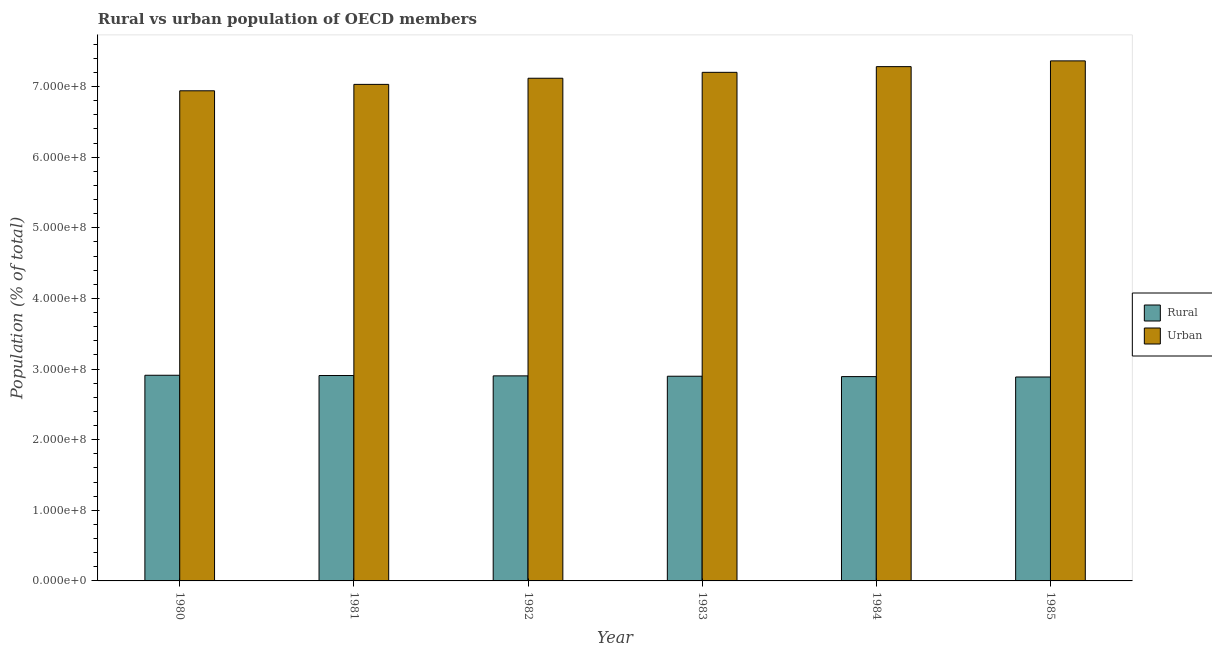How many groups of bars are there?
Keep it short and to the point. 6. Are the number of bars per tick equal to the number of legend labels?
Keep it short and to the point. Yes. Are the number of bars on each tick of the X-axis equal?
Provide a short and direct response. Yes. How many bars are there on the 1st tick from the right?
Give a very brief answer. 2. What is the rural population density in 1982?
Ensure brevity in your answer.  2.90e+08. Across all years, what is the maximum urban population density?
Make the answer very short. 7.36e+08. Across all years, what is the minimum rural population density?
Provide a succinct answer. 2.89e+08. In which year was the rural population density maximum?
Ensure brevity in your answer.  1980. What is the total rural population density in the graph?
Provide a succinct answer. 1.74e+09. What is the difference between the urban population density in 1981 and that in 1985?
Your response must be concise. -3.33e+07. What is the difference between the urban population density in 1980 and the rural population density in 1983?
Your response must be concise. -2.61e+07. What is the average urban population density per year?
Offer a very short reply. 7.16e+08. What is the ratio of the rural population density in 1981 to that in 1984?
Provide a succinct answer. 1.01. Is the rural population density in 1981 less than that in 1985?
Your answer should be compact. No. What is the difference between the highest and the second highest urban population density?
Your response must be concise. 8.16e+06. What is the difference between the highest and the lowest urban population density?
Offer a terse response. 4.24e+07. Is the sum of the urban population density in 1980 and 1984 greater than the maximum rural population density across all years?
Make the answer very short. Yes. What does the 2nd bar from the left in 1982 represents?
Offer a terse response. Urban. What does the 2nd bar from the right in 1980 represents?
Your answer should be compact. Rural. How many bars are there?
Give a very brief answer. 12. Are all the bars in the graph horizontal?
Give a very brief answer. No. How many years are there in the graph?
Make the answer very short. 6. What is the difference between two consecutive major ticks on the Y-axis?
Ensure brevity in your answer.  1.00e+08. Are the values on the major ticks of Y-axis written in scientific E-notation?
Your answer should be very brief. Yes. Does the graph contain any zero values?
Offer a very short reply. No. Where does the legend appear in the graph?
Keep it short and to the point. Center right. How are the legend labels stacked?
Provide a succinct answer. Vertical. What is the title of the graph?
Give a very brief answer. Rural vs urban population of OECD members. What is the label or title of the Y-axis?
Offer a terse response. Population (% of total). What is the Population (% of total) of Rural in 1980?
Provide a succinct answer. 2.91e+08. What is the Population (% of total) of Urban in 1980?
Give a very brief answer. 6.94e+08. What is the Population (% of total) of Rural in 1981?
Your answer should be compact. 2.91e+08. What is the Population (% of total) in Urban in 1981?
Ensure brevity in your answer.  7.03e+08. What is the Population (% of total) of Rural in 1982?
Offer a very short reply. 2.90e+08. What is the Population (% of total) in Urban in 1982?
Offer a very short reply. 7.12e+08. What is the Population (% of total) in Rural in 1983?
Offer a very short reply. 2.90e+08. What is the Population (% of total) of Urban in 1983?
Offer a very short reply. 7.20e+08. What is the Population (% of total) of Rural in 1984?
Your answer should be very brief. 2.89e+08. What is the Population (% of total) in Urban in 1984?
Ensure brevity in your answer.  7.28e+08. What is the Population (% of total) in Rural in 1985?
Keep it short and to the point. 2.89e+08. What is the Population (% of total) in Urban in 1985?
Keep it short and to the point. 7.36e+08. Across all years, what is the maximum Population (% of total) in Rural?
Keep it short and to the point. 2.91e+08. Across all years, what is the maximum Population (% of total) of Urban?
Make the answer very short. 7.36e+08. Across all years, what is the minimum Population (% of total) in Rural?
Offer a terse response. 2.89e+08. Across all years, what is the minimum Population (% of total) of Urban?
Keep it short and to the point. 6.94e+08. What is the total Population (% of total) of Rural in the graph?
Offer a very short reply. 1.74e+09. What is the total Population (% of total) of Urban in the graph?
Provide a short and direct response. 4.29e+09. What is the difference between the Population (% of total) in Rural in 1980 and that in 1981?
Provide a succinct answer. 3.88e+05. What is the difference between the Population (% of total) of Urban in 1980 and that in 1981?
Provide a short and direct response. -9.08e+06. What is the difference between the Population (% of total) in Rural in 1980 and that in 1982?
Your answer should be compact. 8.75e+05. What is the difference between the Population (% of total) of Urban in 1980 and that in 1982?
Make the answer very short. -1.78e+07. What is the difference between the Population (% of total) in Rural in 1980 and that in 1983?
Your answer should be very brief. 1.37e+06. What is the difference between the Population (% of total) of Urban in 1980 and that in 1983?
Your response must be concise. -2.61e+07. What is the difference between the Population (% of total) in Rural in 1980 and that in 1984?
Keep it short and to the point. 1.90e+06. What is the difference between the Population (% of total) in Urban in 1980 and that in 1984?
Keep it short and to the point. -3.42e+07. What is the difference between the Population (% of total) in Rural in 1980 and that in 1985?
Provide a short and direct response. 2.45e+06. What is the difference between the Population (% of total) in Urban in 1980 and that in 1985?
Your answer should be very brief. -4.24e+07. What is the difference between the Population (% of total) of Rural in 1981 and that in 1982?
Your response must be concise. 4.87e+05. What is the difference between the Population (% of total) of Urban in 1981 and that in 1982?
Provide a short and direct response. -8.70e+06. What is the difference between the Population (% of total) of Rural in 1981 and that in 1983?
Offer a very short reply. 9.79e+05. What is the difference between the Population (% of total) of Urban in 1981 and that in 1983?
Keep it short and to the point. -1.71e+07. What is the difference between the Population (% of total) in Rural in 1981 and that in 1984?
Provide a short and direct response. 1.51e+06. What is the difference between the Population (% of total) of Urban in 1981 and that in 1984?
Keep it short and to the point. -2.51e+07. What is the difference between the Population (% of total) of Rural in 1981 and that in 1985?
Your response must be concise. 2.06e+06. What is the difference between the Population (% of total) of Urban in 1981 and that in 1985?
Your answer should be very brief. -3.33e+07. What is the difference between the Population (% of total) of Rural in 1982 and that in 1983?
Give a very brief answer. 4.91e+05. What is the difference between the Population (% of total) of Urban in 1982 and that in 1983?
Your answer should be compact. -8.36e+06. What is the difference between the Population (% of total) of Rural in 1982 and that in 1984?
Keep it short and to the point. 1.03e+06. What is the difference between the Population (% of total) in Urban in 1982 and that in 1984?
Keep it short and to the point. -1.64e+07. What is the difference between the Population (% of total) of Rural in 1982 and that in 1985?
Offer a very short reply. 1.57e+06. What is the difference between the Population (% of total) of Urban in 1982 and that in 1985?
Give a very brief answer. -2.46e+07. What is the difference between the Population (% of total) in Rural in 1983 and that in 1984?
Offer a very short reply. 5.34e+05. What is the difference between the Population (% of total) of Urban in 1983 and that in 1984?
Your response must be concise. -8.07e+06. What is the difference between the Population (% of total) in Rural in 1983 and that in 1985?
Give a very brief answer. 1.08e+06. What is the difference between the Population (% of total) of Urban in 1983 and that in 1985?
Ensure brevity in your answer.  -1.62e+07. What is the difference between the Population (% of total) in Rural in 1984 and that in 1985?
Your answer should be compact. 5.47e+05. What is the difference between the Population (% of total) of Urban in 1984 and that in 1985?
Give a very brief answer. -8.16e+06. What is the difference between the Population (% of total) of Rural in 1980 and the Population (% of total) of Urban in 1981?
Provide a succinct answer. -4.12e+08. What is the difference between the Population (% of total) of Rural in 1980 and the Population (% of total) of Urban in 1982?
Offer a very short reply. -4.21e+08. What is the difference between the Population (% of total) of Rural in 1980 and the Population (% of total) of Urban in 1983?
Offer a very short reply. -4.29e+08. What is the difference between the Population (% of total) in Rural in 1980 and the Population (% of total) in Urban in 1984?
Your answer should be compact. -4.37e+08. What is the difference between the Population (% of total) in Rural in 1980 and the Population (% of total) in Urban in 1985?
Provide a succinct answer. -4.45e+08. What is the difference between the Population (% of total) of Rural in 1981 and the Population (% of total) of Urban in 1982?
Provide a succinct answer. -4.21e+08. What is the difference between the Population (% of total) of Rural in 1981 and the Population (% of total) of Urban in 1983?
Your answer should be very brief. -4.29e+08. What is the difference between the Population (% of total) of Rural in 1981 and the Population (% of total) of Urban in 1984?
Give a very brief answer. -4.37e+08. What is the difference between the Population (% of total) of Rural in 1981 and the Population (% of total) of Urban in 1985?
Offer a very short reply. -4.46e+08. What is the difference between the Population (% of total) of Rural in 1982 and the Population (% of total) of Urban in 1983?
Provide a short and direct response. -4.30e+08. What is the difference between the Population (% of total) of Rural in 1982 and the Population (% of total) of Urban in 1984?
Provide a succinct answer. -4.38e+08. What is the difference between the Population (% of total) in Rural in 1982 and the Population (% of total) in Urban in 1985?
Offer a very short reply. -4.46e+08. What is the difference between the Population (% of total) in Rural in 1983 and the Population (% of total) in Urban in 1984?
Ensure brevity in your answer.  -4.38e+08. What is the difference between the Population (% of total) of Rural in 1983 and the Population (% of total) of Urban in 1985?
Keep it short and to the point. -4.47e+08. What is the difference between the Population (% of total) of Rural in 1984 and the Population (% of total) of Urban in 1985?
Provide a short and direct response. -4.47e+08. What is the average Population (% of total) of Rural per year?
Give a very brief answer. 2.90e+08. What is the average Population (% of total) in Urban per year?
Offer a terse response. 7.16e+08. In the year 1980, what is the difference between the Population (% of total) of Rural and Population (% of total) of Urban?
Your answer should be compact. -4.03e+08. In the year 1981, what is the difference between the Population (% of total) in Rural and Population (% of total) in Urban?
Your answer should be very brief. -4.12e+08. In the year 1982, what is the difference between the Population (% of total) of Rural and Population (% of total) of Urban?
Provide a short and direct response. -4.21e+08. In the year 1983, what is the difference between the Population (% of total) of Rural and Population (% of total) of Urban?
Offer a terse response. -4.30e+08. In the year 1984, what is the difference between the Population (% of total) in Rural and Population (% of total) in Urban?
Offer a terse response. -4.39e+08. In the year 1985, what is the difference between the Population (% of total) in Rural and Population (% of total) in Urban?
Offer a very short reply. -4.48e+08. What is the ratio of the Population (% of total) in Urban in 1980 to that in 1981?
Your answer should be compact. 0.99. What is the ratio of the Population (% of total) in Rural in 1980 to that in 1982?
Keep it short and to the point. 1. What is the ratio of the Population (% of total) in Urban in 1980 to that in 1983?
Offer a terse response. 0.96. What is the ratio of the Population (% of total) in Rural in 1980 to that in 1984?
Make the answer very short. 1.01. What is the ratio of the Population (% of total) in Urban in 1980 to that in 1984?
Ensure brevity in your answer.  0.95. What is the ratio of the Population (% of total) of Rural in 1980 to that in 1985?
Keep it short and to the point. 1.01. What is the ratio of the Population (% of total) in Urban in 1980 to that in 1985?
Your response must be concise. 0.94. What is the ratio of the Population (% of total) in Rural in 1981 to that in 1982?
Offer a very short reply. 1. What is the ratio of the Population (% of total) of Urban in 1981 to that in 1982?
Offer a very short reply. 0.99. What is the ratio of the Population (% of total) in Rural in 1981 to that in 1983?
Your answer should be compact. 1. What is the ratio of the Population (% of total) in Urban in 1981 to that in 1983?
Make the answer very short. 0.98. What is the ratio of the Population (% of total) in Rural in 1981 to that in 1984?
Your answer should be compact. 1.01. What is the ratio of the Population (% of total) of Urban in 1981 to that in 1984?
Provide a short and direct response. 0.97. What is the ratio of the Population (% of total) of Rural in 1981 to that in 1985?
Provide a short and direct response. 1.01. What is the ratio of the Population (% of total) in Urban in 1981 to that in 1985?
Make the answer very short. 0.95. What is the ratio of the Population (% of total) of Urban in 1982 to that in 1983?
Ensure brevity in your answer.  0.99. What is the ratio of the Population (% of total) in Urban in 1982 to that in 1984?
Keep it short and to the point. 0.98. What is the ratio of the Population (% of total) in Rural in 1982 to that in 1985?
Offer a terse response. 1.01. What is the ratio of the Population (% of total) in Urban in 1982 to that in 1985?
Offer a very short reply. 0.97. What is the ratio of the Population (% of total) in Urban in 1983 to that in 1984?
Offer a terse response. 0.99. What is the ratio of the Population (% of total) in Rural in 1983 to that in 1985?
Offer a terse response. 1. What is the ratio of the Population (% of total) in Urban in 1983 to that in 1985?
Your answer should be compact. 0.98. What is the ratio of the Population (% of total) of Rural in 1984 to that in 1985?
Offer a very short reply. 1. What is the ratio of the Population (% of total) in Urban in 1984 to that in 1985?
Make the answer very short. 0.99. What is the difference between the highest and the second highest Population (% of total) of Rural?
Offer a very short reply. 3.88e+05. What is the difference between the highest and the second highest Population (% of total) of Urban?
Offer a very short reply. 8.16e+06. What is the difference between the highest and the lowest Population (% of total) in Rural?
Ensure brevity in your answer.  2.45e+06. What is the difference between the highest and the lowest Population (% of total) of Urban?
Offer a terse response. 4.24e+07. 